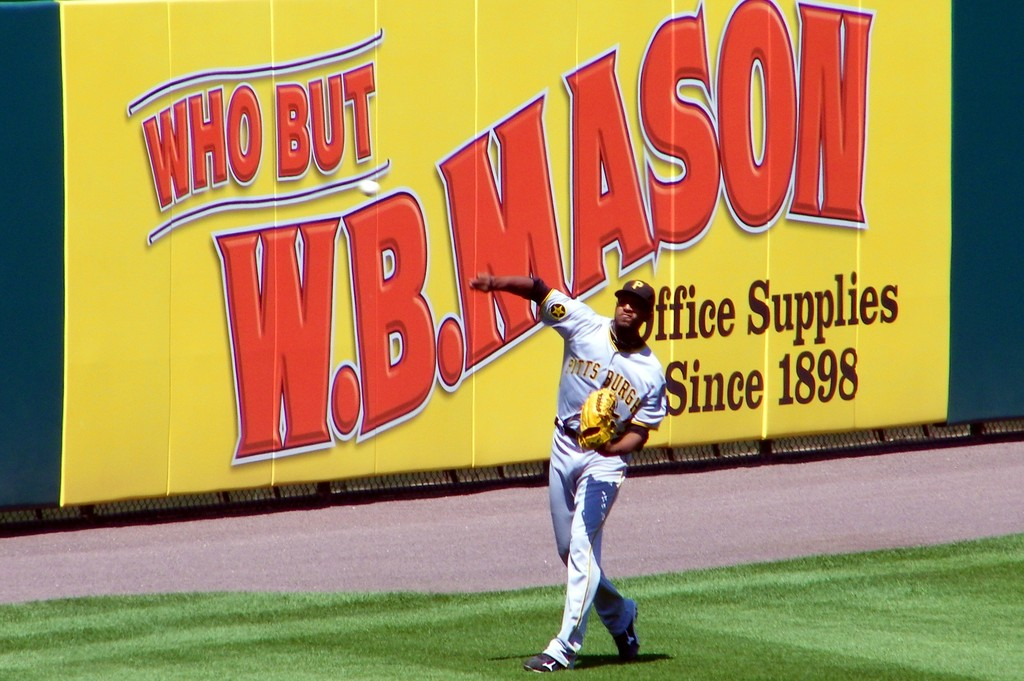What might be the significance of the W.B. Mason advertisement at a baseball game? W.B. Mason, as a prominent supplier of office products, often sponsors sporting events to enhance their brand visibility and connect with a wide audience, leveraging the communal and highly visible nature of sports venues for advertising. 